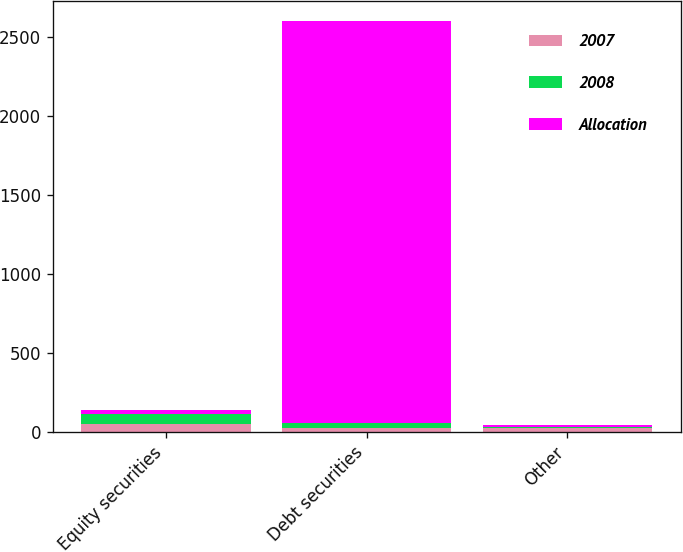Convert chart. <chart><loc_0><loc_0><loc_500><loc_500><stacked_bar_chart><ecel><fcel>Equity securities<fcel>Debt securities<fcel>Other<nl><fcel>2007<fcel>50<fcel>25<fcel>25<nl><fcel>2008<fcel>63<fcel>32<fcel>5<nl><fcel>Allocation<fcel>28.5<fcel>2540<fcel>15<nl></chart> 